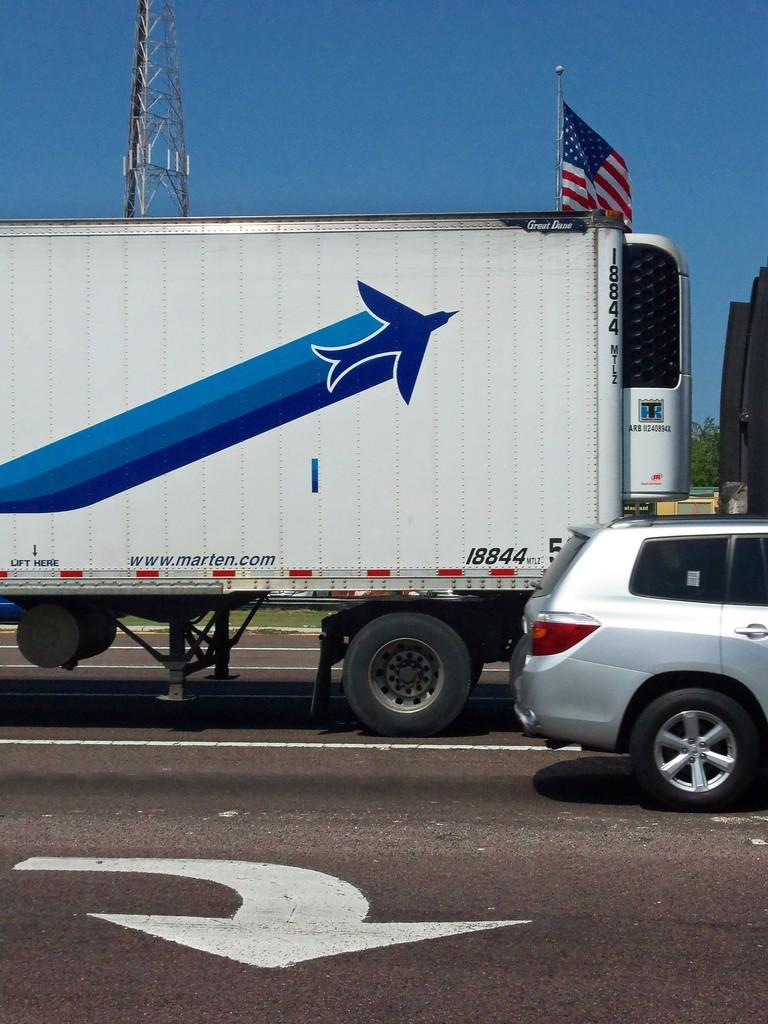What is happening on the road in the image? There are vehicles on the road in the image. What type of structure can be seen in the image? There is a metal frame visible in the image. What type of vegetation is present in the image? There are plants and grass in the image. What is flying in the image? There is a flag in the image. What part of the natural environment is visible in the image? The sky is visible in the image. Can you see a hen laying eggs in the image? There is no hen or eggs present in the image. What type of wound is visible on the flag in the image? There is no wound present on the flag or any other part of the image. 